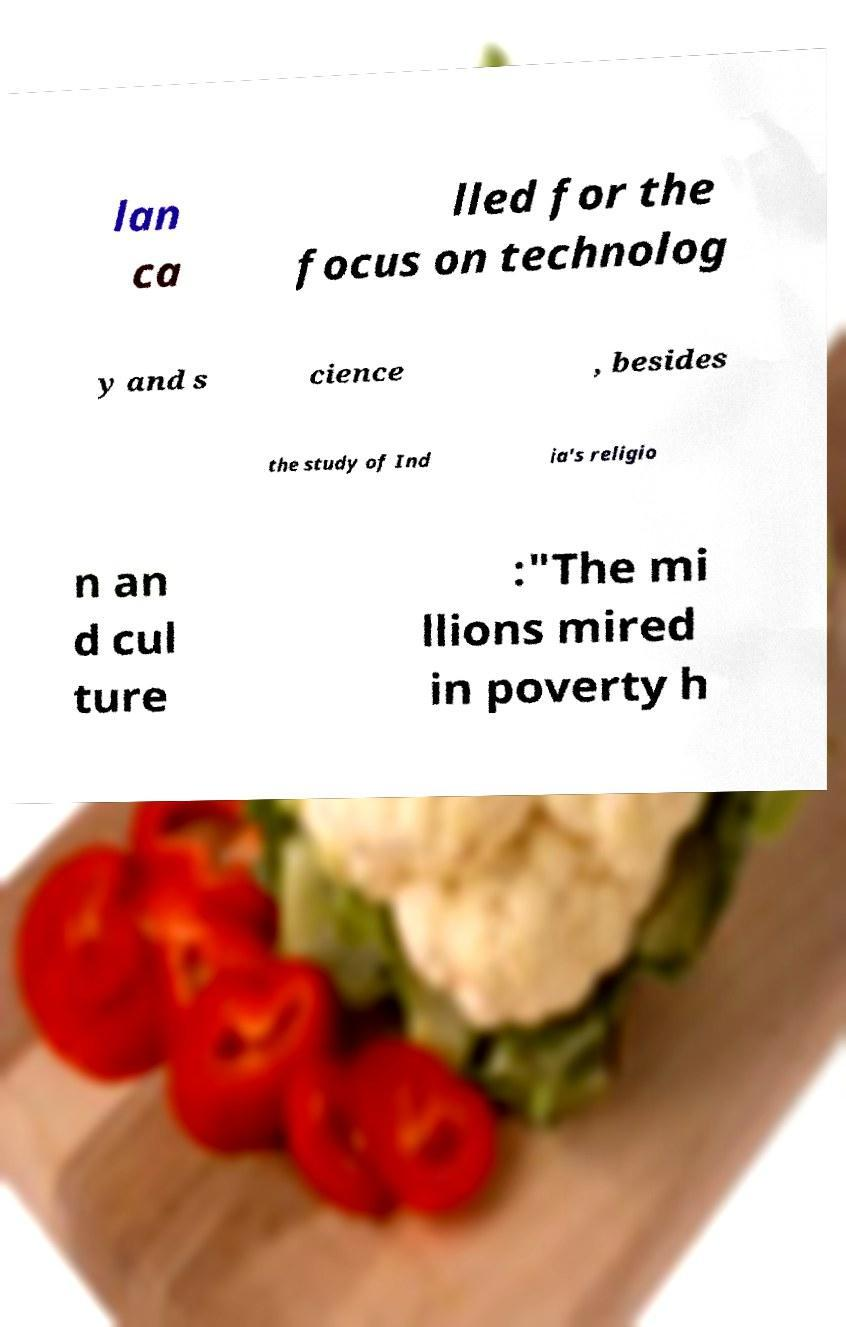Could you assist in decoding the text presented in this image and type it out clearly? lan ca lled for the focus on technolog y and s cience , besides the study of Ind ia's religio n an d cul ture :"The mi llions mired in poverty h 